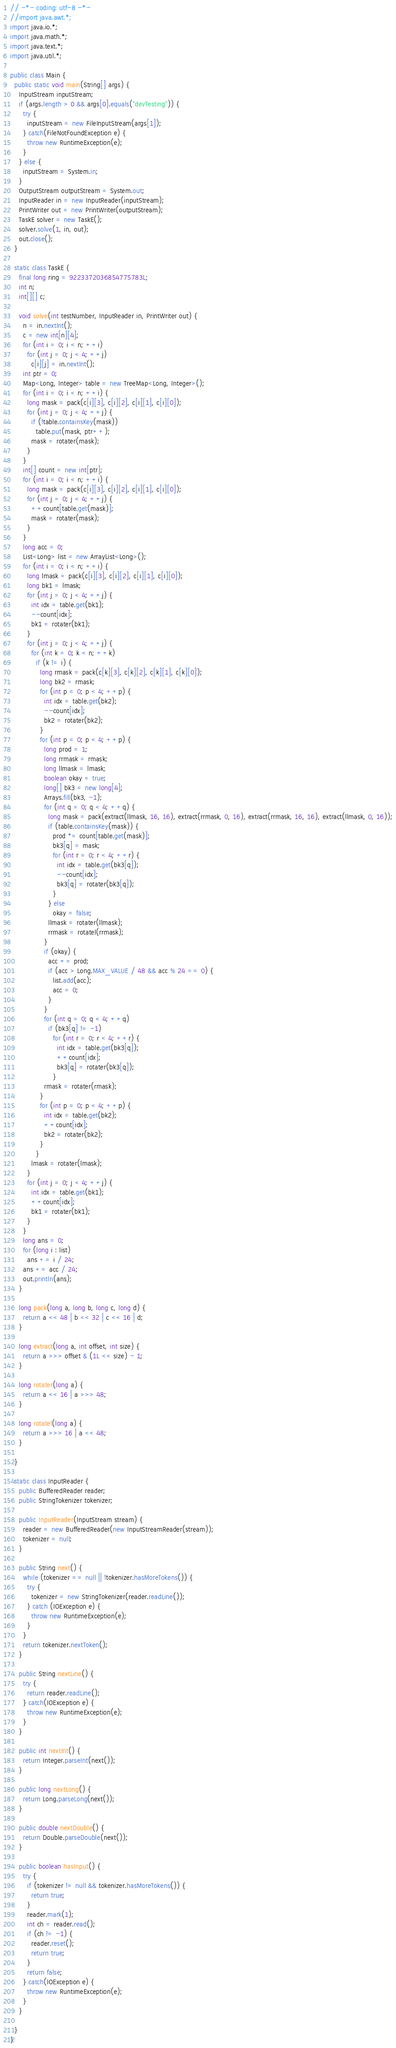<code> <loc_0><loc_0><loc_500><loc_500><_Java_>// -*- coding: utf-8 -*-
//import java.awt.*;
import java.io.*;
import java.math.*;
import java.text.*;
import java.util.*;

public class Main {
  public static void main(String[] args) {
    InputStream inputStream;
    if (args.length > 0 && args[0].equals("devTesting")) {
      try {
        inputStream = new FileInputStream(args[1]);
      } catch(FileNotFoundException e) {
        throw new RuntimeException(e);
      }
    } else {
      inputStream = System.in;
    }
    OutputStream outputStream = System.out;
    InputReader in = new InputReader(inputStream);
    PrintWriter out = new PrintWriter(outputStream);
    TaskE solver = new TaskE();
    solver.solve(1, in, out);
    out.close();
  }
  
  static class TaskE {    
    final long ring = 9223372036854775783L;
    int n;
    int[][] c;
    
    void solve(int testNumber, InputReader in, PrintWriter out) {
      n = in.nextInt();
      c = new int[n][4];
      for (int i = 0; i < n; ++i)
        for (int j = 0; j < 4; ++j)
          c[i][j] = in.nextInt();
      int ptr = 0;
      Map<Long, Integer> table = new TreeMap<Long, Integer>();
      for (int i = 0; i < n; ++i) {
        long mask = pack(c[i][3], c[i][2], c[i][1], c[i][0]);
        for (int j = 0; j < 4; ++j) {
          if (!table.containsKey(mask))
            table.put(mask, ptr++);
          mask = rotater(mask);
        }
      }
      int[] count = new int[ptr];
      for (int i = 0; i < n; ++i) {
        long mask = pack(c[i][3], c[i][2], c[i][1], c[i][0]);
        for (int j = 0; j < 4; ++j) {
          ++count[table.get(mask)];
          mask = rotater(mask);
        }
      }
      long acc = 0;
      List<Long> list = new ArrayList<Long>();
      for (int i = 0; i < n; ++i) {
        long lmask = pack(c[i][3], c[i][2], c[i][1], c[i][0]);
        long bk1 = lmask;
        for (int j = 0; j < 4; ++j) {
          int idx = table.get(bk1);
          --count[idx];
          bk1 = rotater(bk1);
        }
        for (int j = 0; j < 4; ++j) {
          for (int k = 0; k < n; ++k)
            if (k != i) {
              long rmask = pack(c[k][3], c[k][2], c[k][1], c[k][0]);
              long bk2 = rmask;
              for (int p = 0; p < 4; ++p) {
                int idx = table.get(bk2);
                --count[idx];
                bk2 = rotater(bk2);
              }
              for (int p = 0; p < 4; ++p) {
                long prod = 1;
                long rrmask = rmask;
                long llmask = lmask;
                boolean okay = true;
                long[] bk3 = new long[4];
                Arrays.fill(bk3, -1);
                for (int q = 0; q < 4; ++q) {
                  long mask = pack(extract(llmask, 16, 16), extract(rrmask, 0, 16), extract(rrmask, 16, 16), extract(llmask, 0, 16));
                  if (table.containsKey(mask)) {
                    prod *= count[table.get(mask)];
                    bk3[q] = mask;
                    for (int r = 0; r < 4; ++r) {
                      int idx = table.get(bk3[q]);
                      --count[idx];
                      bk3[q] = rotater(bk3[q]);
                    }
                  } else
                    okay = false;
                  llmask = rotater(llmask);
                  rrmask = rotatel(rrmask);
                }
                if (okay) {
                  acc += prod;
                  if (acc > Long.MAX_VALUE / 48 && acc % 24 == 0) {
                    list.add(acc);
                    acc = 0;
                  }
                }
                for (int q = 0; q < 4; ++q)
                  if (bk3[q] != -1)
                    for (int r = 0; r < 4; ++r) {
                      int idx = table.get(bk3[q]);
                      ++count[idx];
                      bk3[q] = rotater(bk3[q]);
                    }
                rmask = rotater(rmask);
              }
              for (int p = 0; p < 4; ++p) {
                int idx = table.get(bk2);
                ++count[idx];
                bk2 = rotater(bk2);
              }
            }
          lmask = rotater(lmask);
        }
        for (int j = 0; j < 4; ++j) {
          int idx = table.get(bk1);
          ++count[idx];
          bk1 = rotater(bk1);
        }
      }
      long ans = 0;
      for (long i : list)
        ans += i / 24;
      ans += acc / 24;
      out.println(ans);
    }
    
    long pack(long a, long b, long c, long d) {
      return a << 48 | b << 32 | c << 16 | d;
    }
    
    long extract(long a, int offset, int size) {
      return a >>> offset & (1L << size) - 1;
    }
    
    long rotater(long a) {
      return a << 16 | a >>> 48;
    }
    
    long rotatel(long a) {
      return a >>> 16 | a << 48;
    }    
    
  }
      
  static class InputReader {
    public BufferedReader reader;
    public StringTokenizer tokenizer;

    public InputReader(InputStream stream) {
      reader = new BufferedReader(new InputStreamReader(stream));
      tokenizer = null;
    }

    public String next() {
      while (tokenizer == null || !tokenizer.hasMoreTokens()) {
        try {
          tokenizer = new StringTokenizer(reader.readLine());
        } catch (IOException e) {
          throw new RuntimeException(e);
        }
      }
      return tokenizer.nextToken();
    }
    
    public String nextLine() {
      try {
        return reader.readLine();
      } catch(IOException e) {
        throw new RuntimeException(e);
      }
    }

    public int nextInt() {
      return Integer.parseInt(next());
    }

    public long nextLong() {
      return Long.parseLong(next());
    }
    
    public double nextDouble() {
      return Double.parseDouble(next());
    }

    public boolean hasInput() {
      try {
        if (tokenizer != null && tokenizer.hasMoreTokens()) {
          return true;
        }
        reader.mark(1);
        int ch = reader.read();
        if (ch != -1) {
          reader.reset();
          return true;
        }
        return false;
      } catch(IOException e) {
        throw new RuntimeException(e);
      }
    }
    
  }
}</code> 